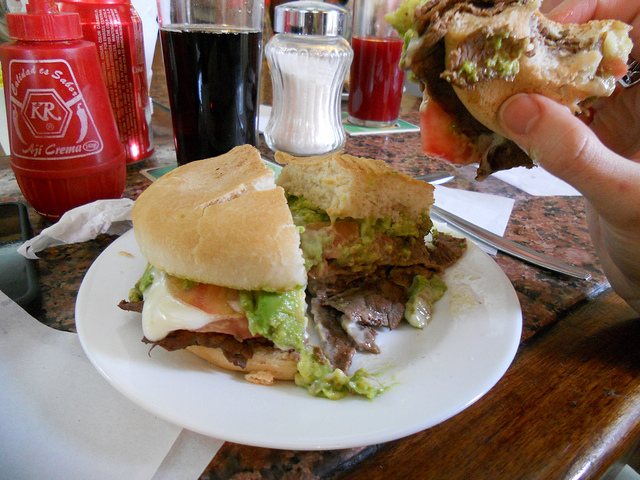Identify and read out the text in this image. KR Crema Sabo 